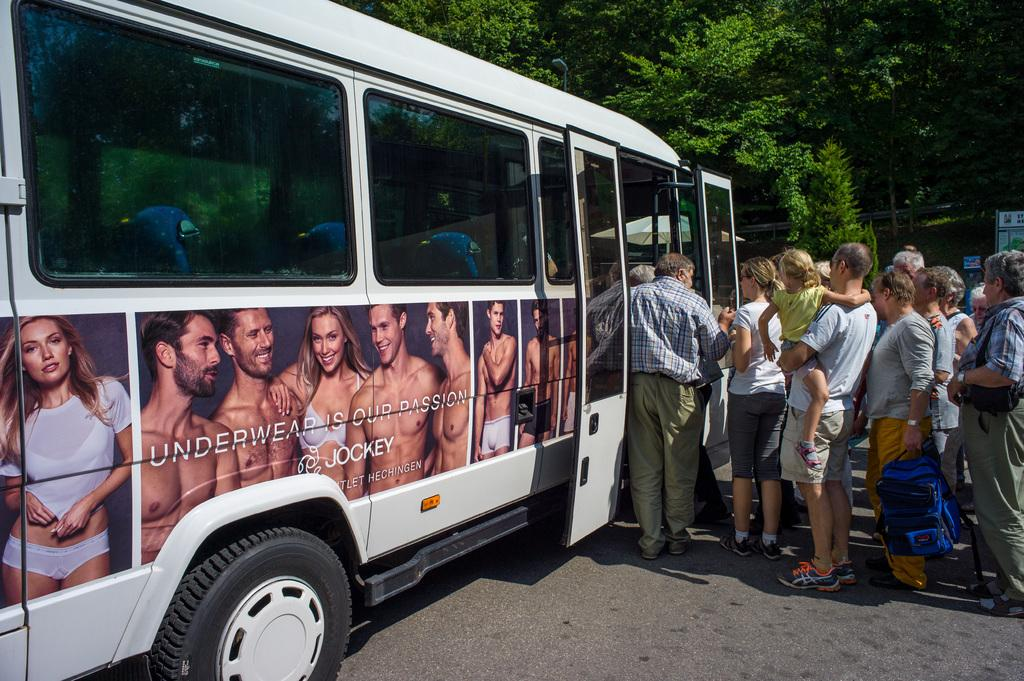<image>
Create a compact narrative representing the image presented. people getting on a white bus that has a jockey underwear ad on the side 